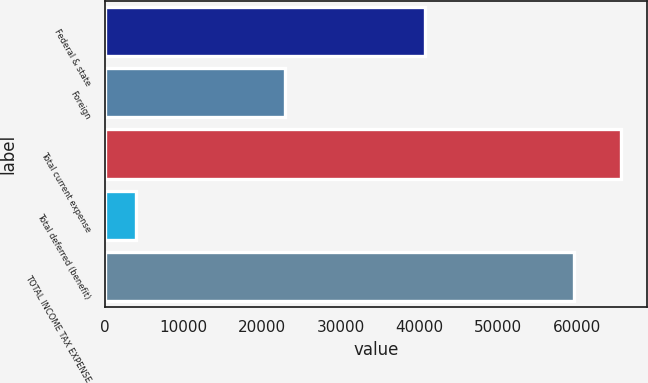<chart> <loc_0><loc_0><loc_500><loc_500><bar_chart><fcel>Federal & state<fcel>Foreign<fcel>Total current expense<fcel>Total deferred (benefit)<fcel>TOTAL INCOME TAX EXPENSE<nl><fcel>40643<fcel>22851<fcel>65588.6<fcel>3868<fcel>59626<nl></chart> 